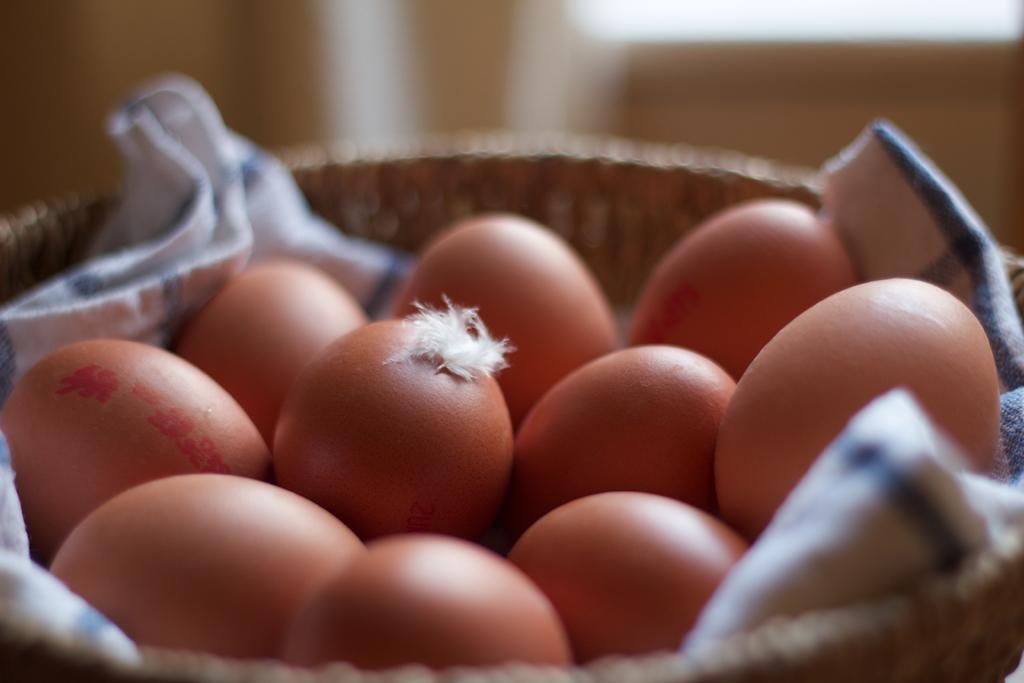What is located in the center of the image? There is a basket in the center of the image. What is inside the basket? There is a cloth and eggs in the basket. Can you describe the background of the image? The background of the image is blurred. What type of structure can be seen in the image? There is no structure present in the image; it features a basket with a cloth and eggs. What type of industry is depicted in the image? There is no industry depicted in the image; it features a basket with a cloth and eggs. 